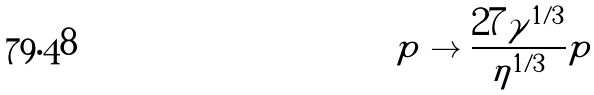Convert formula to latex. <formula><loc_0><loc_0><loc_500><loc_500>p \to \frac { 2 7 \gamma ^ { 1 / 3 } } { \eta ^ { 1 / 3 } } p</formula> 